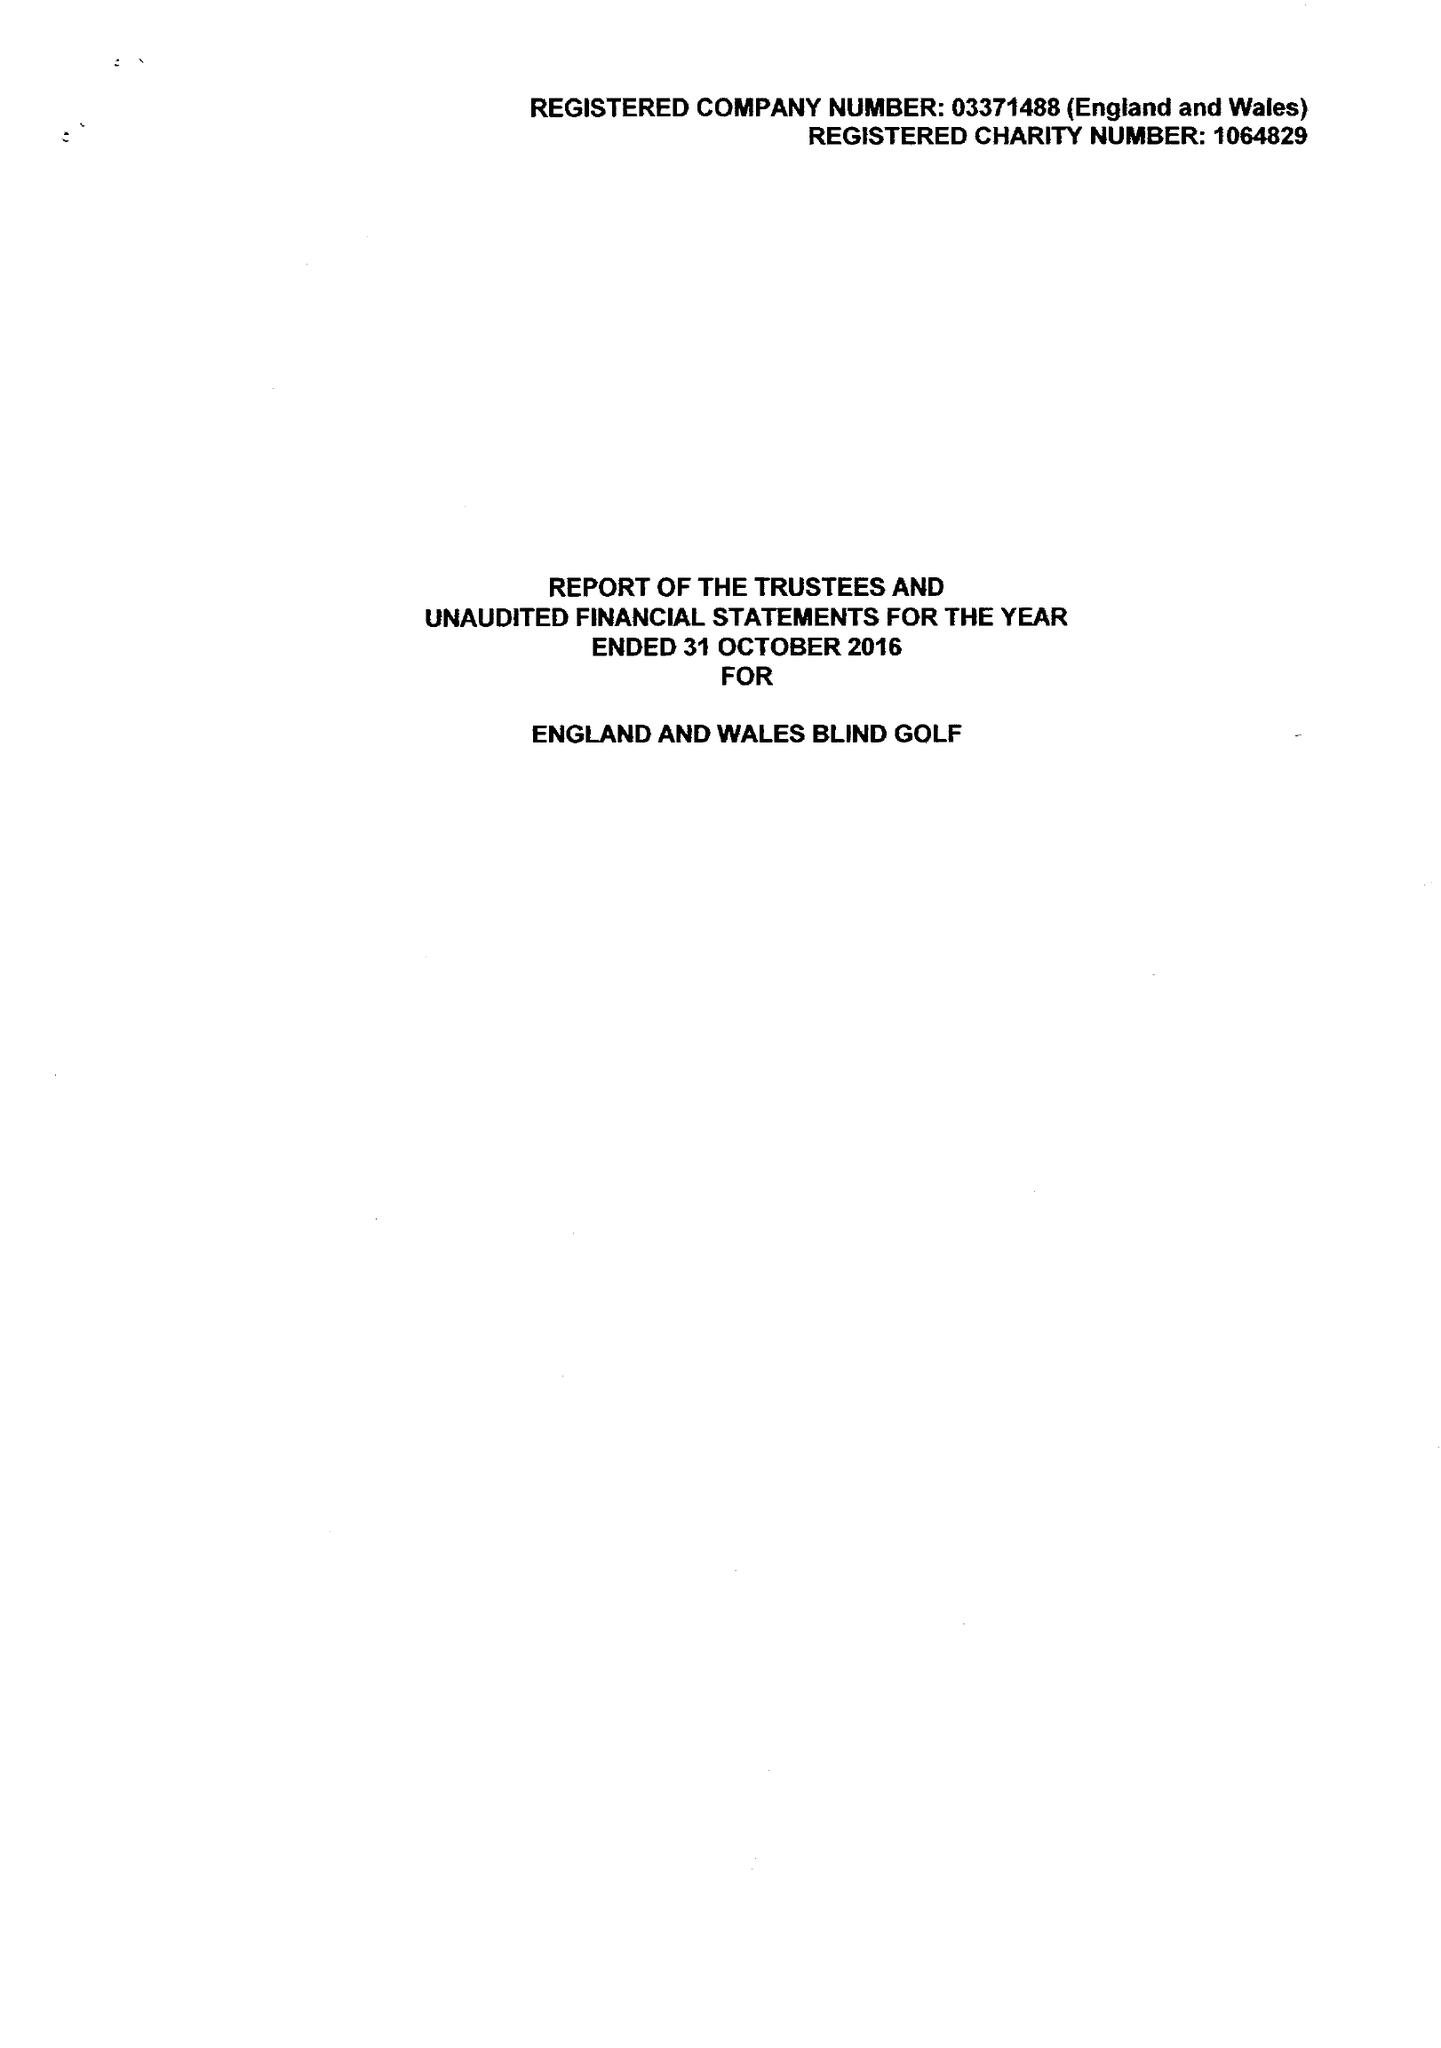What is the value for the address__street_line?
Answer the question using a single word or phrase. NORTH STREET 